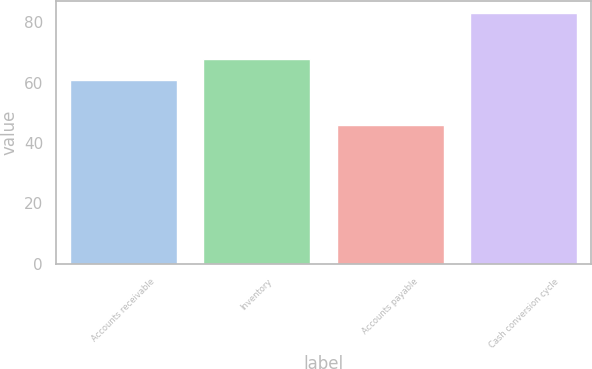Convert chart. <chart><loc_0><loc_0><loc_500><loc_500><bar_chart><fcel>Accounts receivable<fcel>Inventory<fcel>Accounts payable<fcel>Cash conversion cycle<nl><fcel>61<fcel>68<fcel>46<fcel>83<nl></chart> 